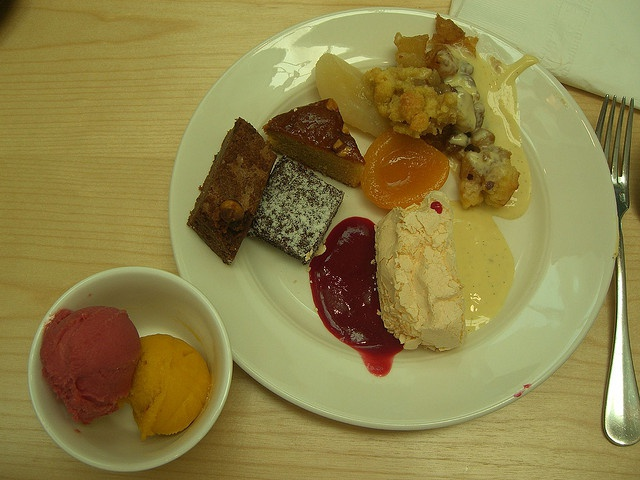Describe the objects in this image and their specific colors. I can see dining table in olive and maroon tones, bowl in black, maroon, and olive tones, cake in black, maroon, and olive tones, fork in black, darkgreen, ivory, and olive tones, and cake in black, darkgreen, and olive tones in this image. 